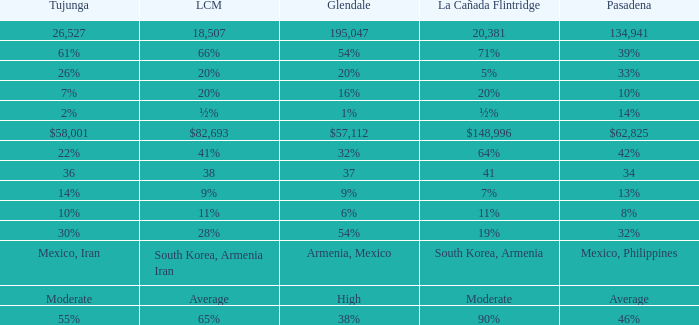What is the percentage of Glendale when Pasadena is 14%? 1%. 